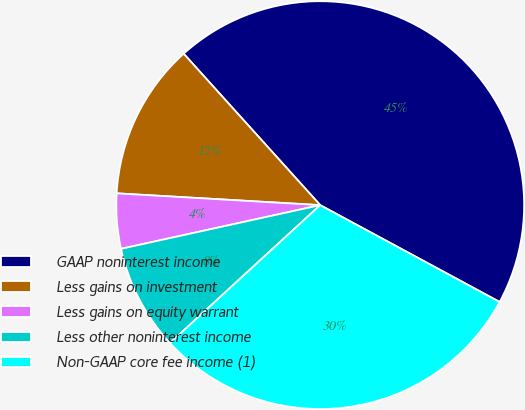Convert chart. <chart><loc_0><loc_0><loc_500><loc_500><pie_chart><fcel>GAAP noninterest income<fcel>Less gains on investment<fcel>Less gains on equity warrant<fcel>Less other noninterest income<fcel>Non-GAAP core fee income (1)<nl><fcel>44.55%<fcel>12.4%<fcel>4.36%<fcel>8.38%<fcel>30.3%<nl></chart> 